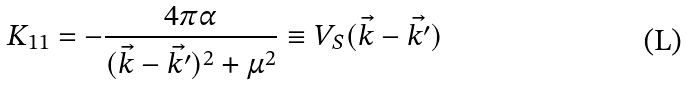Convert formula to latex. <formula><loc_0><loc_0><loc_500><loc_500>K _ { 1 1 } = - \frac { 4 \pi \alpha } { ( \vec { k } - \vec { k ^ { \prime } } ) ^ { 2 } + \mu ^ { 2 } } \equiv V _ { S } ( \vec { k } - \vec { k ^ { \prime } } )</formula> 